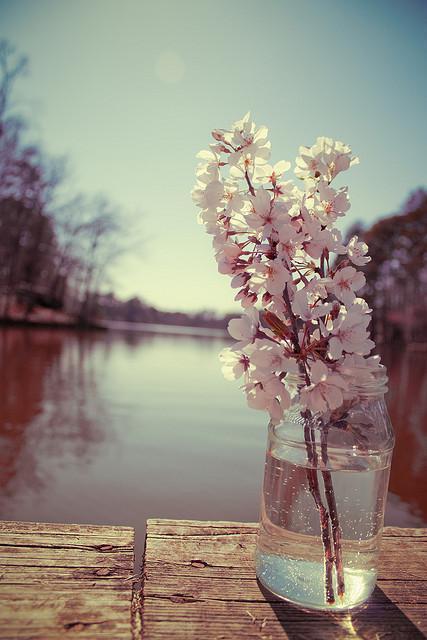How many leafs does this flower have?
Give a very brief answer. 0. 